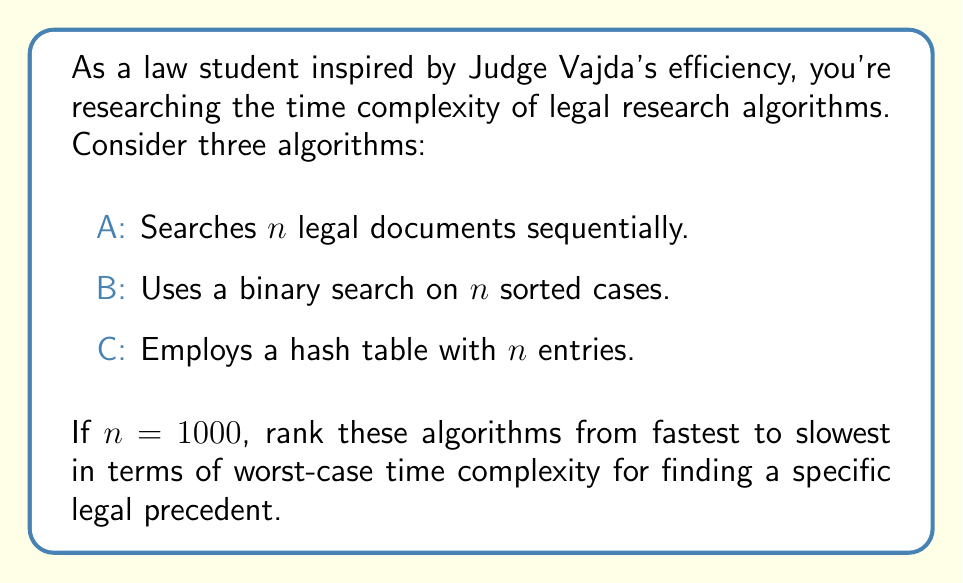Teach me how to tackle this problem. To rank these algorithms, we need to determine their worst-case time complexities:

1. Algorithm A (Sequential Search):
   - Worst case: must search all $n$ documents
   - Time complexity: $O(n)$

2. Algorithm B (Binary Search):
   - Worst case: log base 2 of $n$ comparisons
   - Time complexity: $O(\log_2 n)$

3. Algorithm C (Hash Table):
   - Worst case: all entries collide in one bucket
   - Time complexity: $O(n)$

For $n = 1000$:

A: $O(1000) = O(n)$
B: $O(\log_2 1000) \approx O(10)$
C: $O(1000) = O(n)$

Ranking from fastest to slowest:
1. Algorithm B: $O(\log_2 n)$
2. Algorithm A/C: $O(n)$ (tied)

Algorithm B (binary search) is significantly faster for large $n$, as $\log_2 1000 \approx 10$, which is much smaller than 1000.
Answer: B, A/C (tie) 